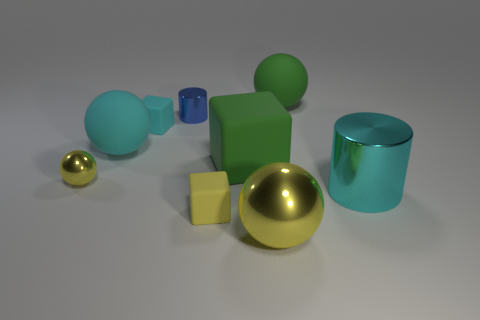The matte sphere that is the same color as the large matte cube is what size?
Give a very brief answer. Large. There is a small cube that is behind the small thing that is in front of the cyan cylinder; what color is it?
Provide a succinct answer. Cyan. Are there any large cylinders of the same color as the big cube?
Make the answer very short. No. The metallic thing that is the same size as the cyan cylinder is what color?
Your answer should be very brief. Yellow. Does the yellow sphere that is left of the big metal sphere have the same material as the big cyan ball?
Offer a terse response. No. Is there a metal thing on the right side of the matte object right of the yellow shiny ball on the right side of the tiny metallic cylinder?
Your response must be concise. Yes. There is a big cyan object to the right of the small yellow block; is it the same shape as the large yellow object?
Keep it short and to the point. No. What shape is the big green matte object behind the rubber block that is to the left of the yellow block?
Ensure brevity in your answer.  Sphere. What size is the green matte thing that is right of the ball in front of the small yellow thing behind the big cylinder?
Ensure brevity in your answer.  Large. What color is the other large thing that is the same shape as the yellow matte thing?
Keep it short and to the point. Green. 